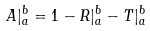<formula> <loc_0><loc_0><loc_500><loc_500>A | _ { a } ^ { b } = 1 - R | _ { a } ^ { b } - T | _ { a } ^ { b }</formula> 